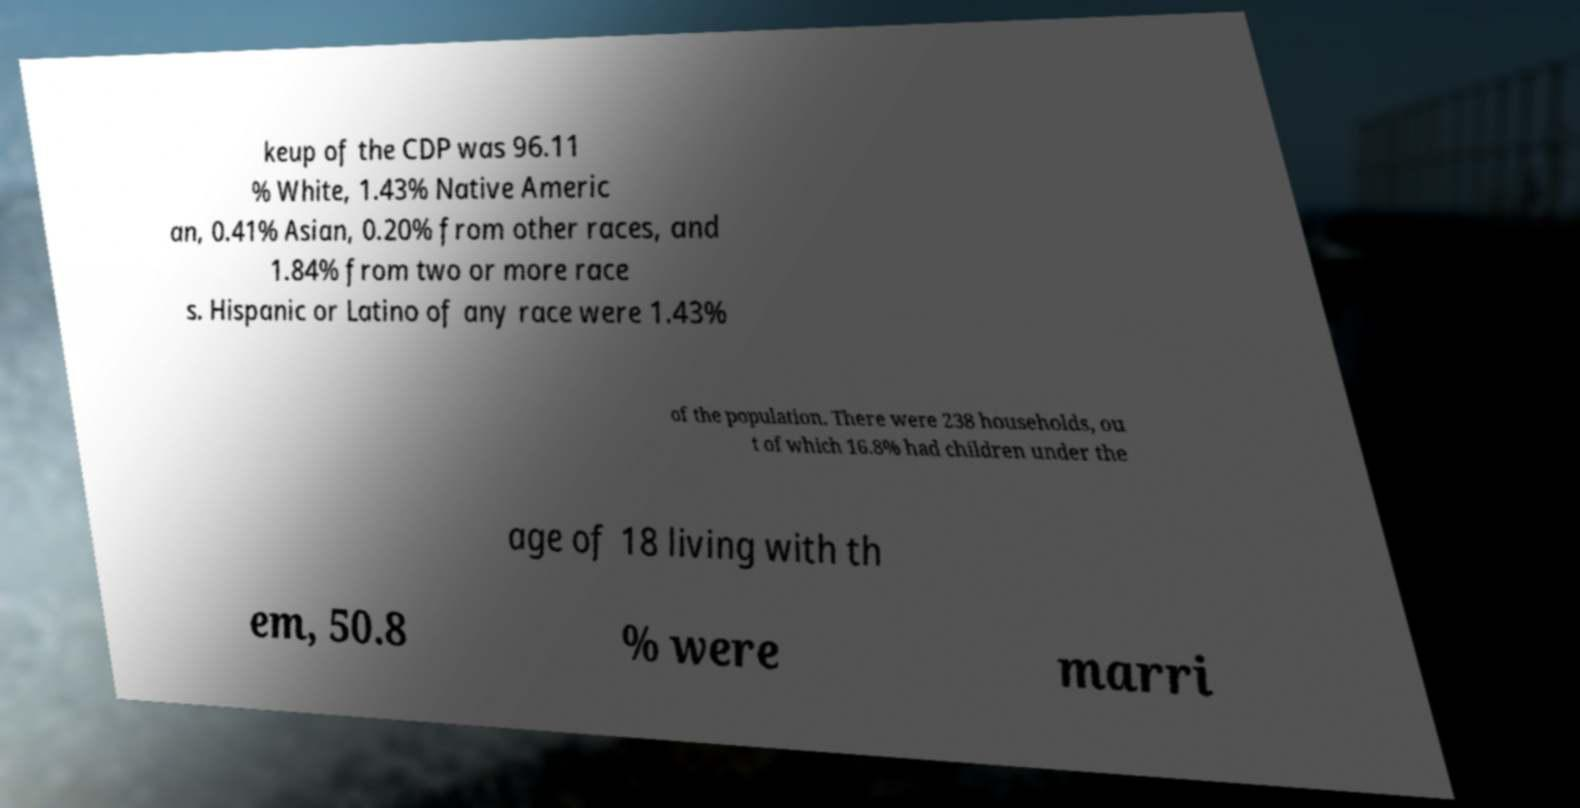There's text embedded in this image that I need extracted. Can you transcribe it verbatim? keup of the CDP was 96.11 % White, 1.43% Native Americ an, 0.41% Asian, 0.20% from other races, and 1.84% from two or more race s. Hispanic or Latino of any race were 1.43% of the population. There were 238 households, ou t of which 16.8% had children under the age of 18 living with th em, 50.8 % were marri 